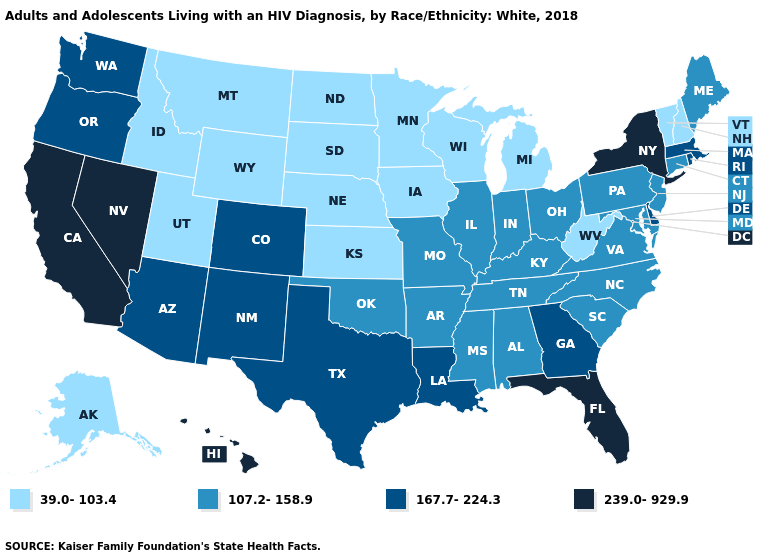Name the states that have a value in the range 107.2-158.9?
Quick response, please. Alabama, Arkansas, Connecticut, Illinois, Indiana, Kentucky, Maine, Maryland, Mississippi, Missouri, New Jersey, North Carolina, Ohio, Oklahoma, Pennsylvania, South Carolina, Tennessee, Virginia. Name the states that have a value in the range 107.2-158.9?
Be succinct. Alabama, Arkansas, Connecticut, Illinois, Indiana, Kentucky, Maine, Maryland, Mississippi, Missouri, New Jersey, North Carolina, Ohio, Oklahoma, Pennsylvania, South Carolina, Tennessee, Virginia. Does the map have missing data?
Give a very brief answer. No. Does Wyoming have the lowest value in the West?
Concise answer only. Yes. How many symbols are there in the legend?
Answer briefly. 4. How many symbols are there in the legend?
Short answer required. 4. Name the states that have a value in the range 167.7-224.3?
Quick response, please. Arizona, Colorado, Delaware, Georgia, Louisiana, Massachusetts, New Mexico, Oregon, Rhode Island, Texas, Washington. What is the highest value in the Northeast ?
Concise answer only. 239.0-929.9. What is the value of Alaska?
Concise answer only. 39.0-103.4. Does the first symbol in the legend represent the smallest category?
Give a very brief answer. Yes. Does Louisiana have a higher value than Montana?
Be succinct. Yes. What is the value of Wisconsin?
Short answer required. 39.0-103.4. Does Tennessee have a higher value than Texas?
Answer briefly. No. Name the states that have a value in the range 239.0-929.9?
Write a very short answer. California, Florida, Hawaii, Nevada, New York. 